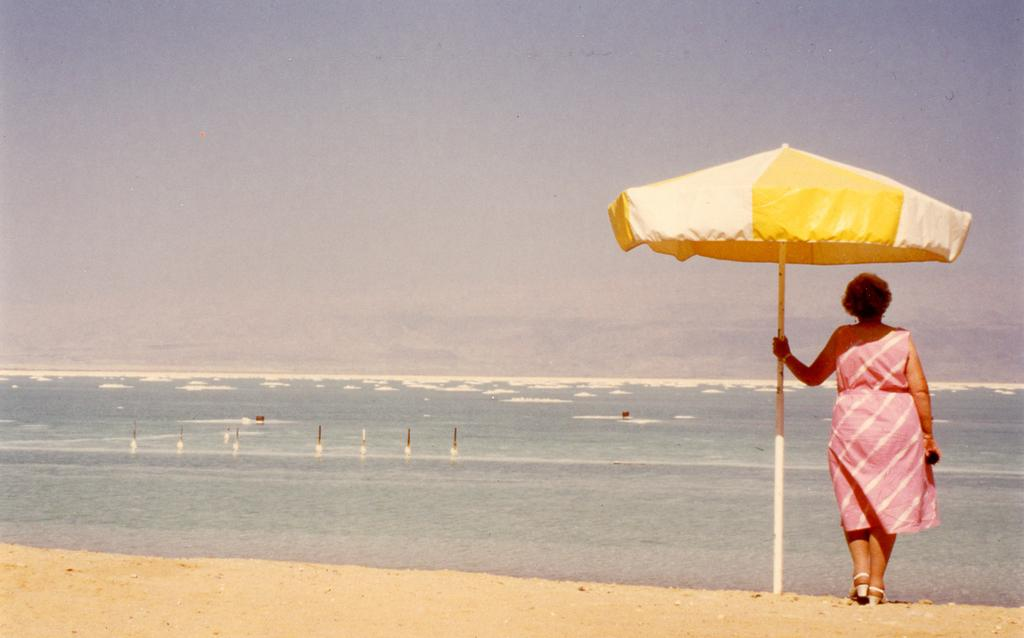What is the main subject of the image? There is a woman standing in the image. Can you describe what the woman is wearing? The woman is wearing clothes and sandals. What is the woman holding in the image? The woman is holding a pole. What other objects can be seen in the image? There is an umbrella, sand, water, and the sky visible in the image. What type of match is being played on the stage in the image? There is no stage or match present in the image; it features a woman standing with an umbrella, sand, water, and the sky visible. Can you tell me where the oven is located in the image? There is no oven present in the image. 